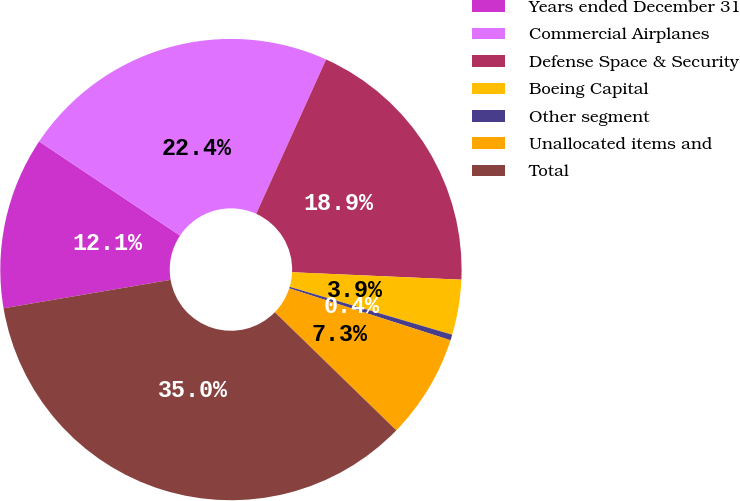Convert chart to OTSL. <chart><loc_0><loc_0><loc_500><loc_500><pie_chart><fcel>Years ended December 31<fcel>Commercial Airplanes<fcel>Defense Space & Security<fcel>Boeing Capital<fcel>Other segment<fcel>Unallocated items and<fcel>Total<nl><fcel>12.06%<fcel>22.4%<fcel>18.93%<fcel>3.86%<fcel>0.4%<fcel>7.32%<fcel>35.04%<nl></chart> 